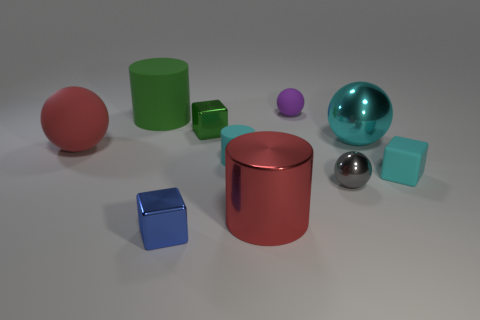What objects are situated closest to the bottom edge of the image? The objects closest to the bottom edge of the image are a small blue cube and a small green cube, both of which appear to be in the foreground of the composition. 